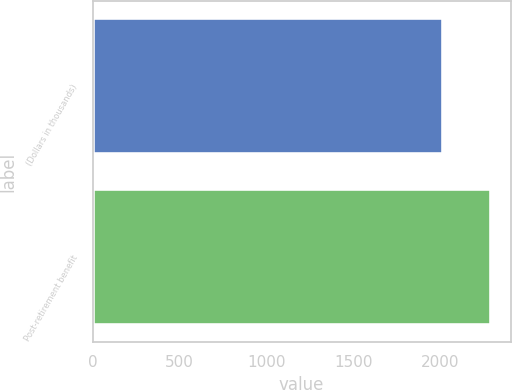<chart> <loc_0><loc_0><loc_500><loc_500><bar_chart><fcel>(Dollars in thousands)<fcel>Post-retirement benefit<nl><fcel>2016<fcel>2293<nl></chart> 